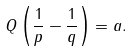<formula> <loc_0><loc_0><loc_500><loc_500>Q \left ( \frac { 1 } { p } - \frac { 1 } { q } \right ) = a .</formula> 